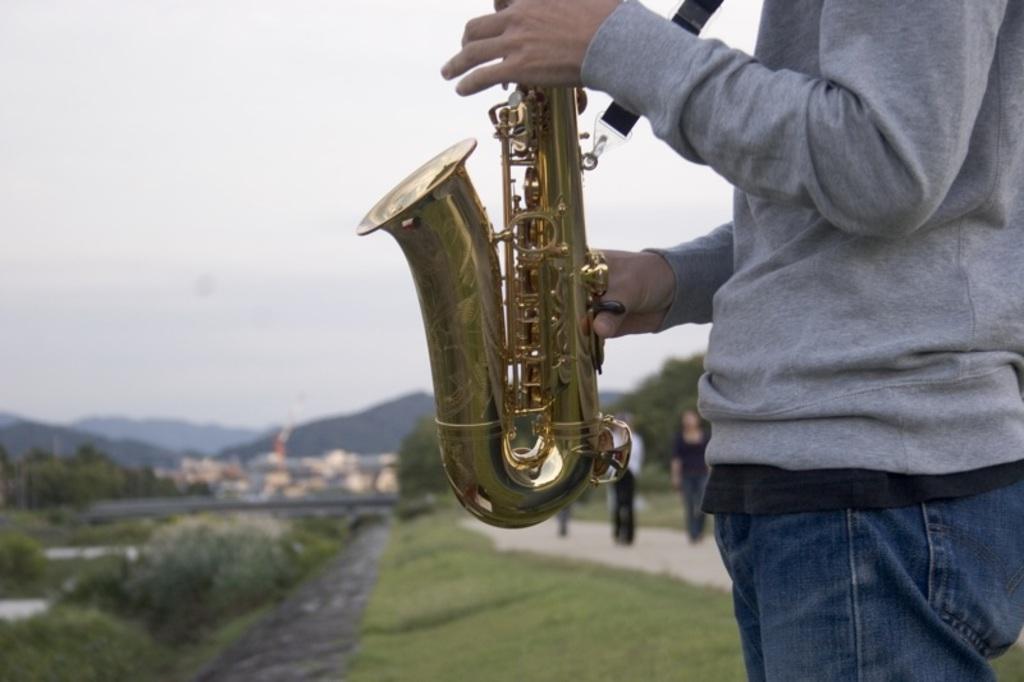Please provide a concise description of this image. In this picture there is a boy on the right side of the image, by holding a trumpet in his hands and there are other people and greenery in the background area of the image, which is blur. 